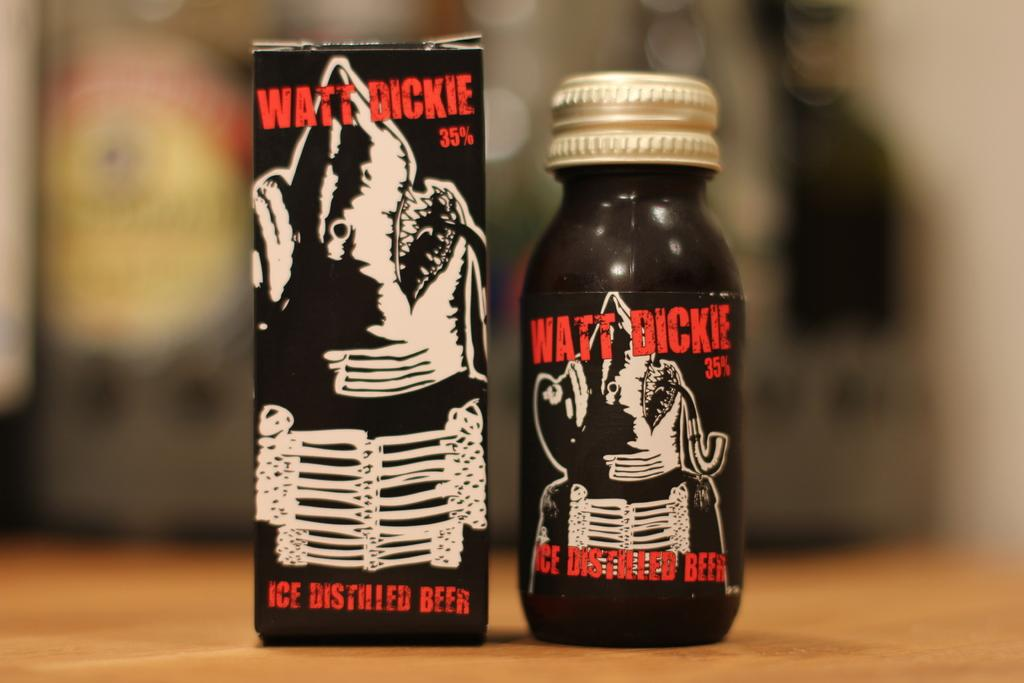<image>
Give a short and clear explanation of the subsequent image. A package of distilled beer next to a bottle of the same beer. 